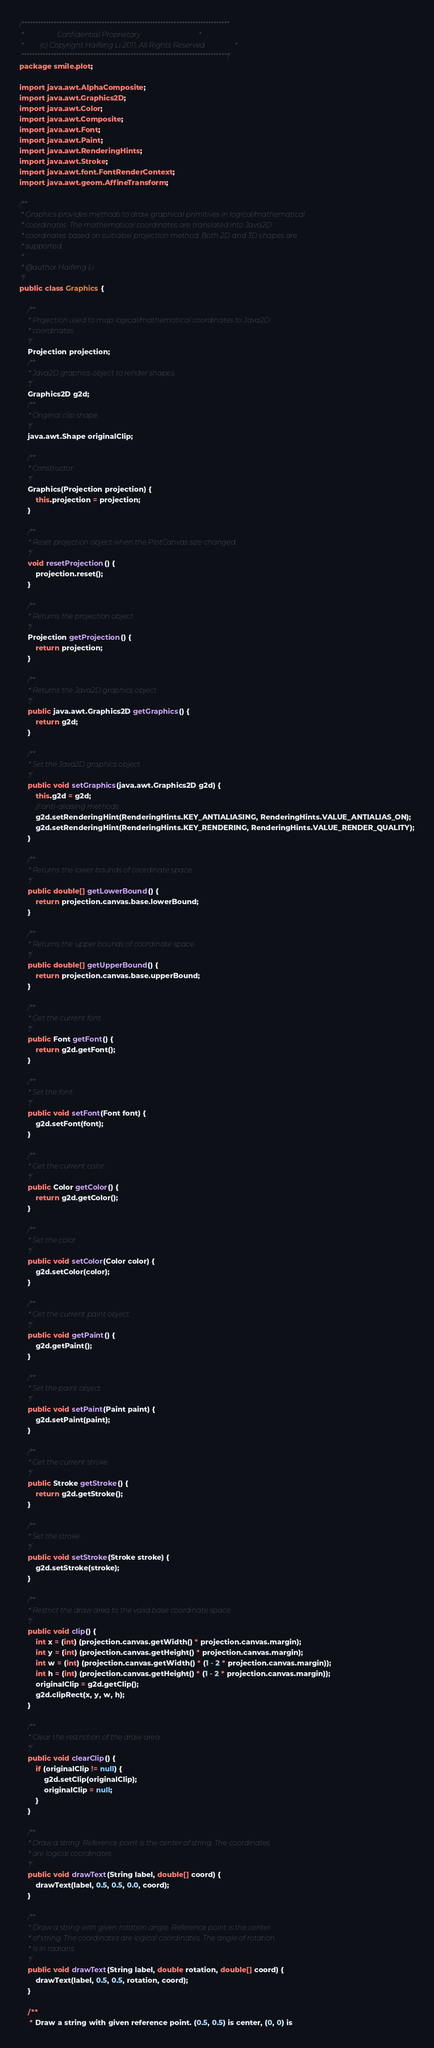<code> <loc_0><loc_0><loc_500><loc_500><_Java_>/******************************************************************************
 *                   Confidential Proprietary                                 *
 *         (c) Copyright Haifeng Li 2011, All Rights Reserved                 *
 ******************************************************************************/
package smile.plot;

import java.awt.AlphaComposite;
import java.awt.Graphics2D;
import java.awt.Color;
import java.awt.Composite;
import java.awt.Font;
import java.awt.Paint;
import java.awt.RenderingHints;
import java.awt.Stroke;
import java.awt.font.FontRenderContext;
import java.awt.geom.AffineTransform;

/**
 * Graphics provides methods to draw graphical primitives in logical/mathematical
 * coordinates. The mathematical coordinates are translated into Java2D
 * coordinates based on suitiabel projection method. Both 2D and 3D shapes are
 * supported.
 *
 * @author Haifeng Li
 */
public class Graphics {

    /**
     * Projection used to map logical/mathematical coordinates to Java2D
     * coordinates.
     */
    Projection projection;
    /**
     * Java2D graphics object to render shapes.
     */
    Graphics2D g2d;
    /**
     * Original clip shape.
     */
    java.awt.Shape originalClip;

    /**
     * Constructor.
     */
    Graphics(Projection projection) {
        this.projection = projection;
    }

    /**
     * Reset projection object when the PlotCanvas size changed.
     */
    void resetProjection() {
        projection.reset();
    }

    /**
     * Returns the projection object.
     */
    Projection getProjection() {
        return projection;
    }

    /**
     * Returns the Java2D graphics object.
     */
    public java.awt.Graphics2D getGraphics() {
        return g2d;
    }

    /**
     * Set the Java2D graphics object.
     */
    public void setGraphics(java.awt.Graphics2D g2d) {
        this.g2d = g2d;
        // anti-aliasing methods
        g2d.setRenderingHint(RenderingHints.KEY_ANTIALIASING, RenderingHints.VALUE_ANTIALIAS_ON);
        g2d.setRenderingHint(RenderingHints.KEY_RENDERING, RenderingHints.VALUE_RENDER_QUALITY);
    }

    /**
     * Returns the lower bounds of coordinate space.
     */
    public double[] getLowerBound() {
        return projection.canvas.base.lowerBound;
    }

    /**
     * Returns the upper bounds of coordinate space.
     */
    public double[] getUpperBound() {
        return projection.canvas.base.upperBound;
    }

    /**
     * Get the current font.
     */
    public Font getFont() {
        return g2d.getFont();
    }

    /**
     * Set the font.
     */
    public void setFont(Font font) {
        g2d.setFont(font);
    }

    /**
     * Get the current color.
     */
    public Color getColor() {
        return g2d.getColor();
    }

    /**
     * Set the color.
     */
    public void setColor(Color color) {
        g2d.setColor(color);
    }

    /**
     * Get the current paint object.
     */
    public void getPaint() {
        g2d.getPaint();
    }

    /**
     * Set the paint object.
     */
    public void setPaint(Paint paint) {
        g2d.setPaint(paint);
    }

    /**
     * Get the current stroke.
     */
    public Stroke getStroke() {
        return g2d.getStroke();
    }

    /**
     * Set the stroke.
     */
    public void setStroke(Stroke stroke) {
        g2d.setStroke(stroke);
    }

    /**
     * Restrict the draw area to the valid base coordinate space.
     */
    public void clip() {
        int x = (int) (projection.canvas.getWidth() * projection.canvas.margin);
        int y = (int) (projection.canvas.getHeight() * projection.canvas.margin);
        int w = (int) (projection.canvas.getWidth() * (1 - 2 * projection.canvas.margin));
        int h = (int) (projection.canvas.getHeight() * (1 - 2 * projection.canvas.margin));
        originalClip = g2d.getClip();
        g2d.clipRect(x, y, w, h);
    }

    /**
     * Clear the restriction of the draw area.
     */
    public void clearClip() {
        if (originalClip != null) {
            g2d.setClip(originalClip);
            originalClip = null;
        }
    }

    /**
     * Draw a string. Reference point is the center of string. The coordinates
     * are logical coordinates.
     */
    public void drawText(String label, double[] coord) {
        drawText(label, 0.5, 0.5, 0.0, coord);
    }

    /**
     * Draw a string with given rotation angle. Reference point is the center
     * of string. The coordinates are logical coordinates. The angle of rotation
     * is in radians.
     */
    public void drawText(String label, double rotation, double[] coord) {
        drawText(label, 0.5, 0.5, rotation, coord);
    }

    /**
     * Draw a string with given reference point. (0.5, 0.5) is center, (0, 0) is</code> 